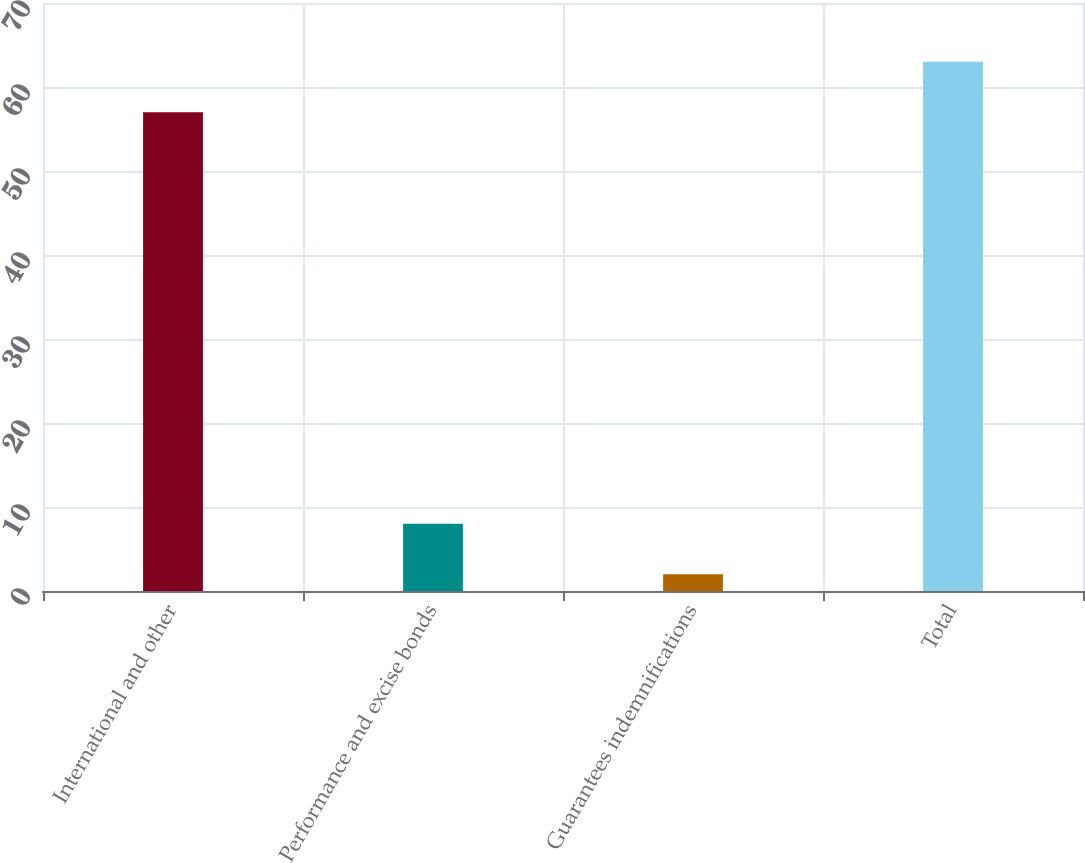Convert chart. <chart><loc_0><loc_0><loc_500><loc_500><bar_chart><fcel>International and other<fcel>Performance and excise bonds<fcel>Guarantees indemnifications<fcel>Total<nl><fcel>57<fcel>8<fcel>2<fcel>63<nl></chart> 